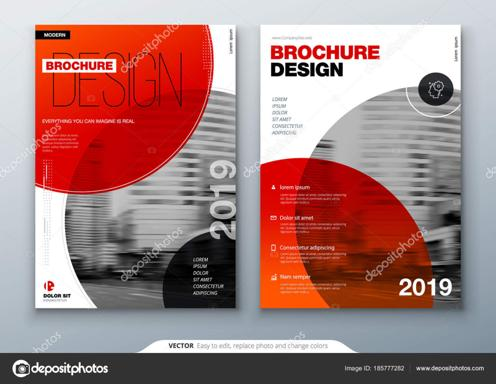What are the main colors used in the brochure template?
 The main colors used in the brochure template are red and black. What are some features of this brochure template mentioned in the image? The brochure template is easy to edit, replace photos, and change colors. It also has an Image ID of 185777282 and can be found on www.depositphotos.com. 